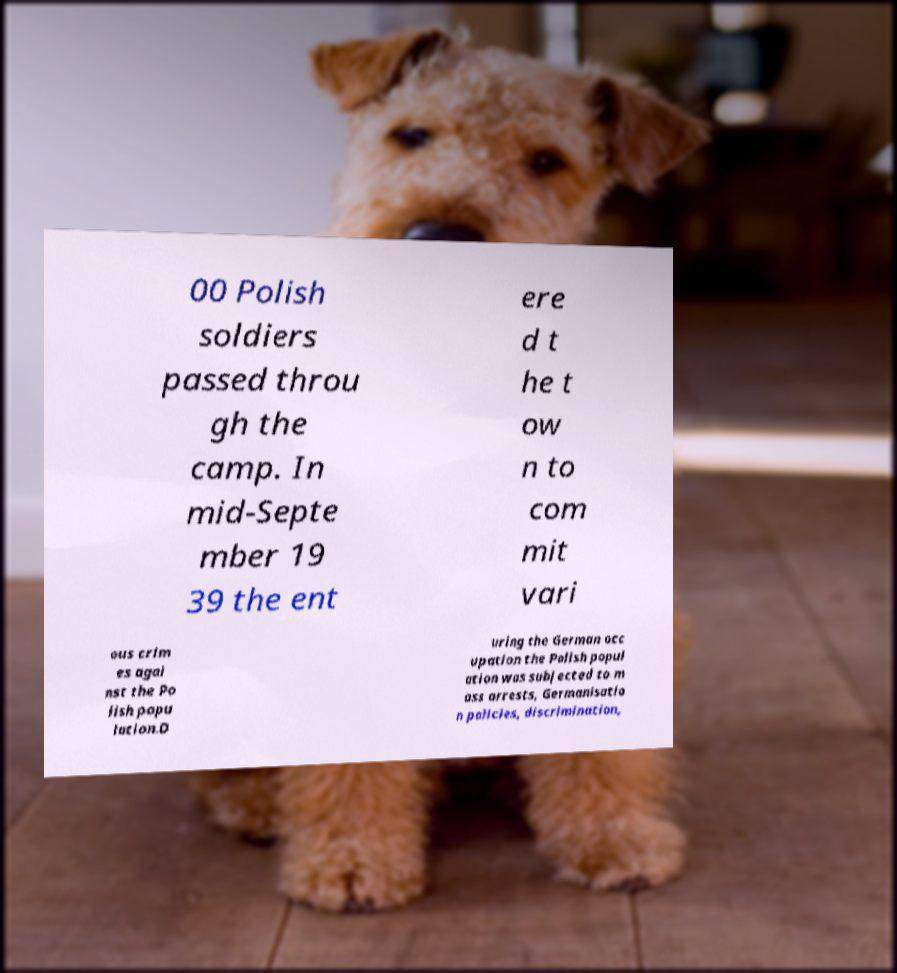Can you read and provide the text displayed in the image?This photo seems to have some interesting text. Can you extract and type it out for me? 00 Polish soldiers passed throu gh the camp. In mid-Septe mber 19 39 the ent ere d t he t ow n to com mit vari ous crim es agai nst the Po lish popu lation.D uring the German occ upation the Polish popul ation was subjected to m ass arrests, Germanisatio n policies, discrimination, 